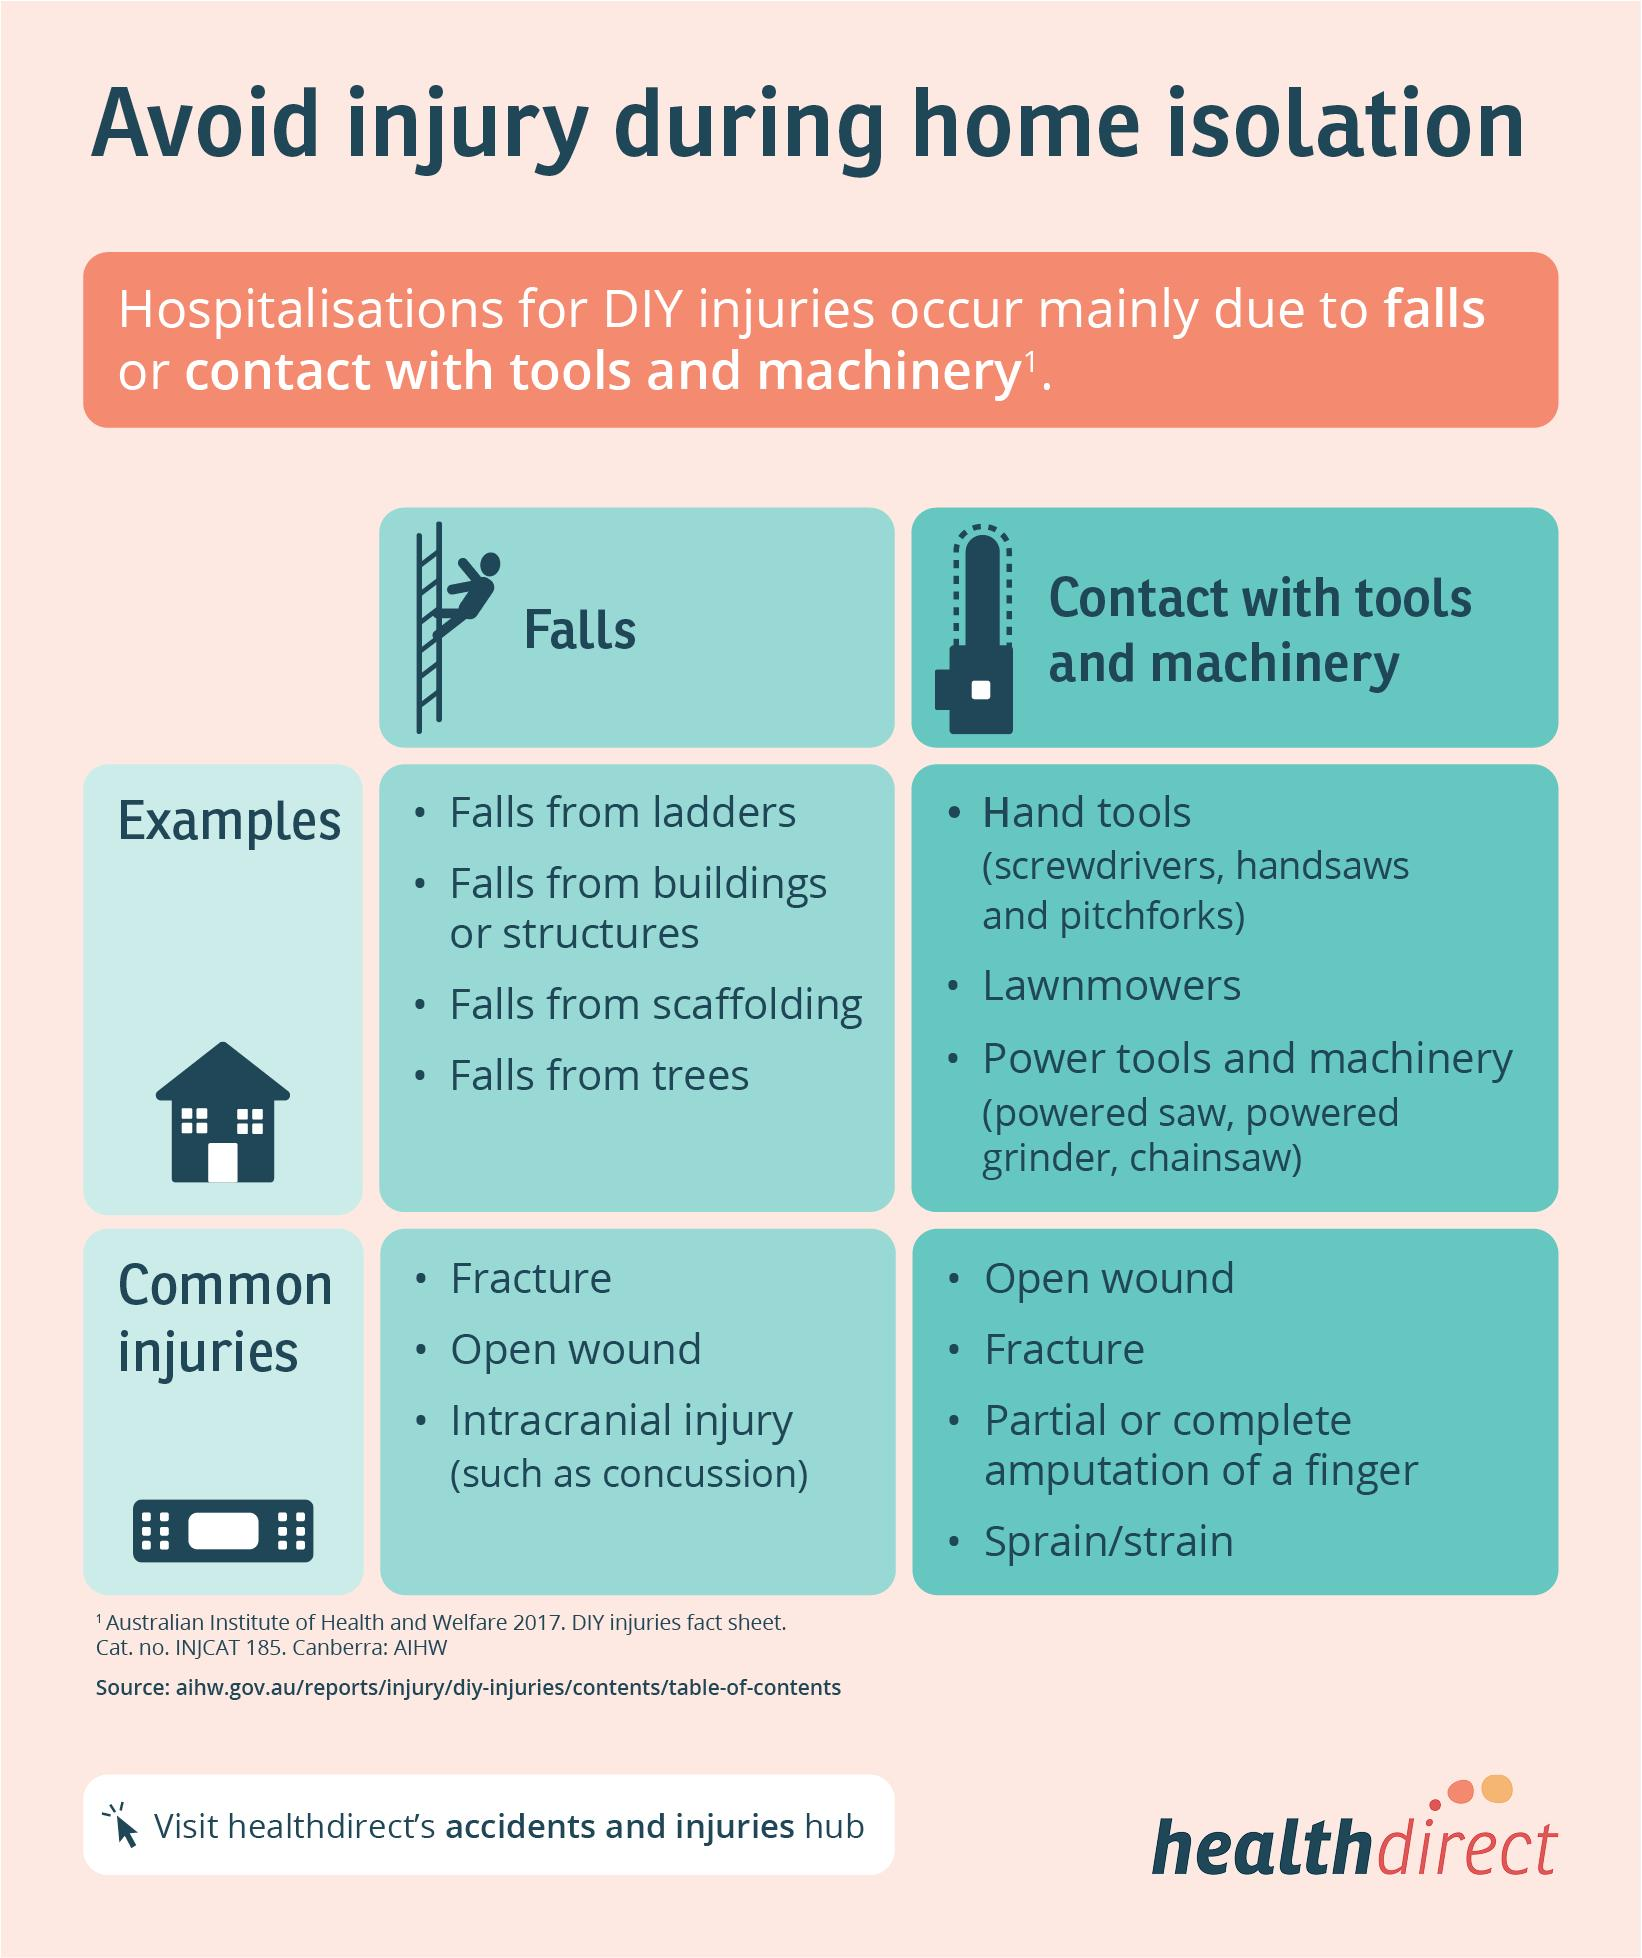Give some essential details in this illustration. Four injuries due to contact with tools and machinery have been reported. It is reported that there are three common types of injuries that result from falls. There are three types of tools and machinery listed. There are four types of falls listed in the infographic. 